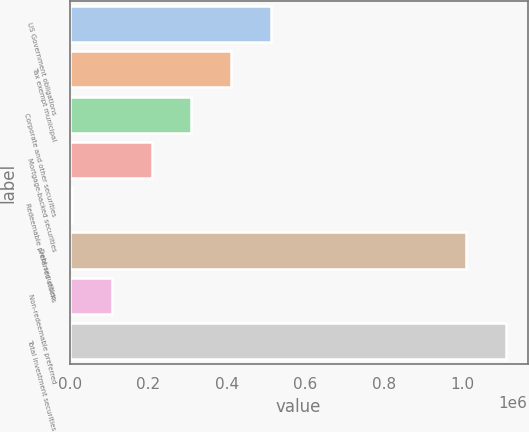<chart> <loc_0><loc_0><loc_500><loc_500><bar_chart><fcel>US Government obligations<fcel>Tax exempt municipal<fcel>Corporate and other securities<fcel>Mortgage-backed securities<fcel>Redeemable preferred stocks<fcel>Debt securities<fcel>Non-redeemable preferred<fcel>Total investment securities<nl><fcel>512011<fcel>410862<fcel>309713<fcel>208564<fcel>6266<fcel>1.0093e+06<fcel>107415<fcel>1.11045e+06<nl></chart> 